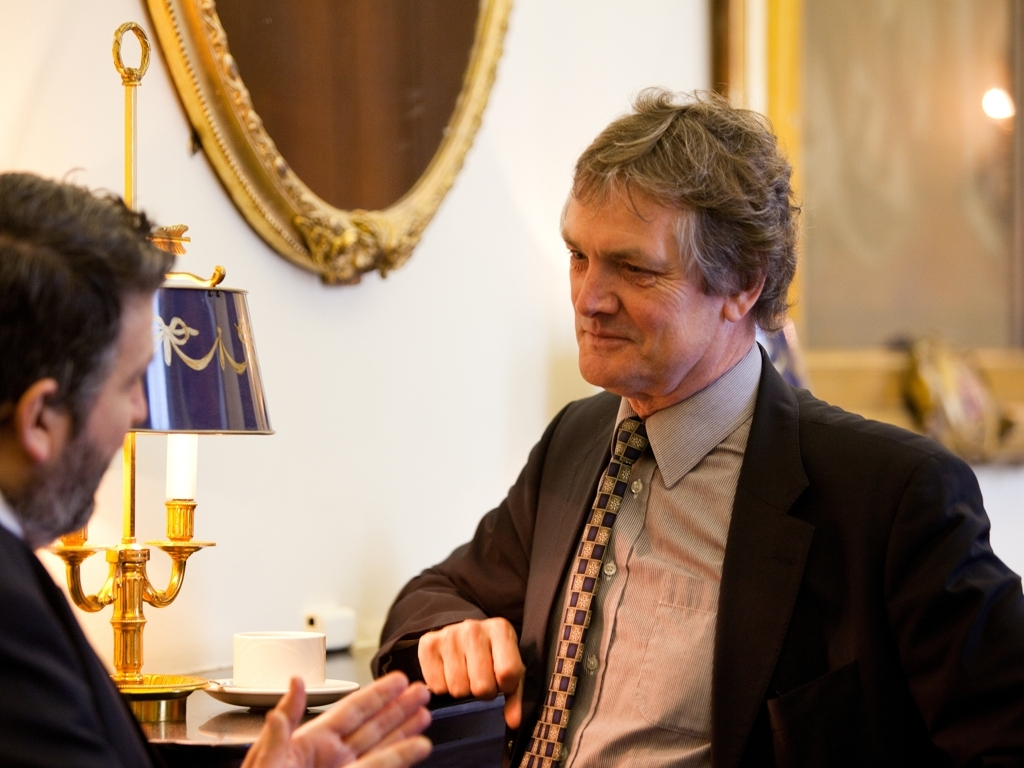What is the mood of the interaction between the two individuals in the image? The mood appears to be quite serious and focused. Both individuals are engaging in what seems to be a substantive conversation, evident by their direct eye contact and the attentive posture of the man listening. It suggests a scene of professional or important personal discussion. 